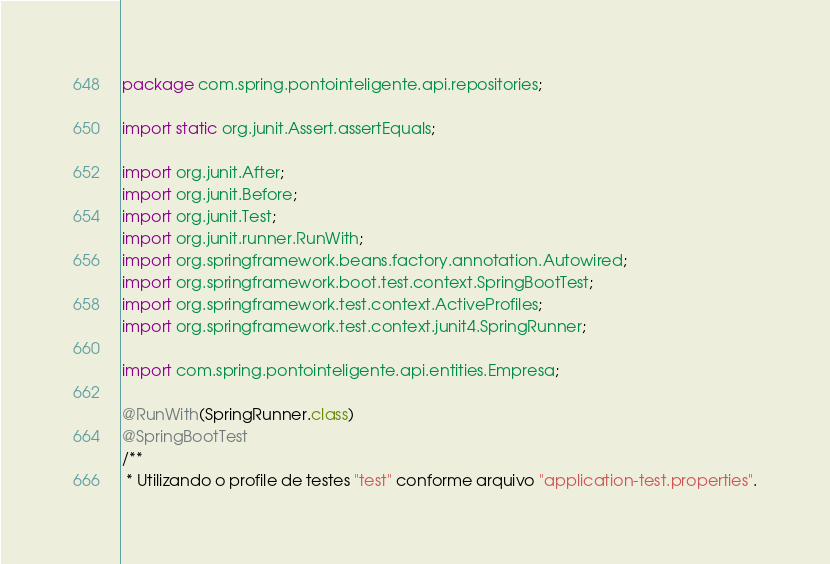Convert code to text. <code><loc_0><loc_0><loc_500><loc_500><_Java_>package com.spring.pontointeligente.api.repositories;

import static org.junit.Assert.assertEquals;

import org.junit.After;
import org.junit.Before;
import org.junit.Test;
import org.junit.runner.RunWith;
import org.springframework.beans.factory.annotation.Autowired;
import org.springframework.boot.test.context.SpringBootTest;
import org.springframework.test.context.ActiveProfiles;
import org.springframework.test.context.junit4.SpringRunner;

import com.spring.pontointeligente.api.entities.Empresa;

@RunWith(SpringRunner.class)
@SpringBootTest
/**
 * Utilizando o profile de testes "test" conforme arquivo "application-test.properties".</code> 